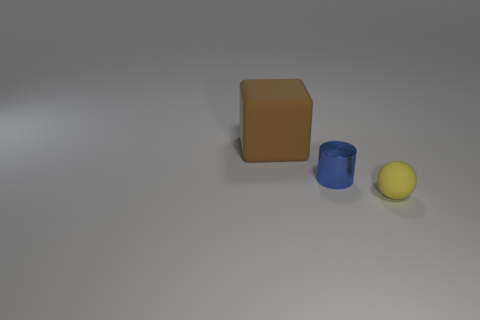What material is the thing that is behind the yellow matte thing and right of the big brown rubber cube?
Offer a terse response. Metal. What number of objects are either tiny matte balls or small brown shiny balls?
Ensure brevity in your answer.  1. Is there anything else that is made of the same material as the tiny cylinder?
Give a very brief answer. No. What is the shape of the metallic thing?
Make the answer very short. Cylinder. What is the shape of the matte object left of the matte thing that is in front of the tiny blue metal thing?
Your answer should be compact. Cube. Is the small thing that is left of the sphere made of the same material as the brown cube?
Give a very brief answer. No. How many brown objects are small things or rubber objects?
Your answer should be compact. 1. Are there any objects that have the same material as the ball?
Your response must be concise. Yes. What shape is the object that is both in front of the big thing and to the left of the small matte thing?
Keep it short and to the point. Cylinder. What number of small things are either blue cylinders or yellow objects?
Your answer should be compact. 2. 